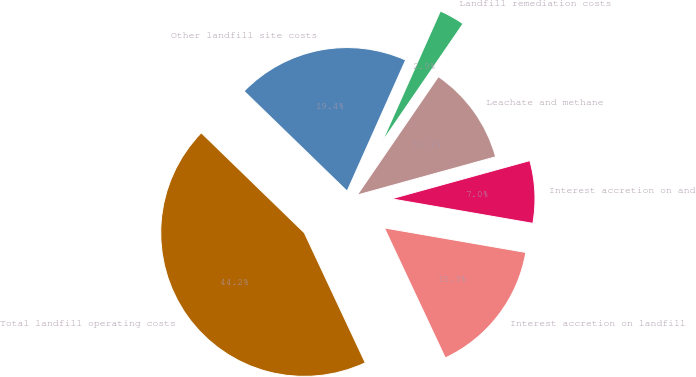Convert chart to OTSL. <chart><loc_0><loc_0><loc_500><loc_500><pie_chart><fcel>Interest accretion on landfill<fcel>Interest accretion on and<fcel>Leachate and methane<fcel>Landfill remediation costs<fcel>Other landfill site costs<fcel>Total landfill operating costs<nl><fcel>15.29%<fcel>7.02%<fcel>11.15%<fcel>2.88%<fcel>19.42%<fcel>44.24%<nl></chart> 